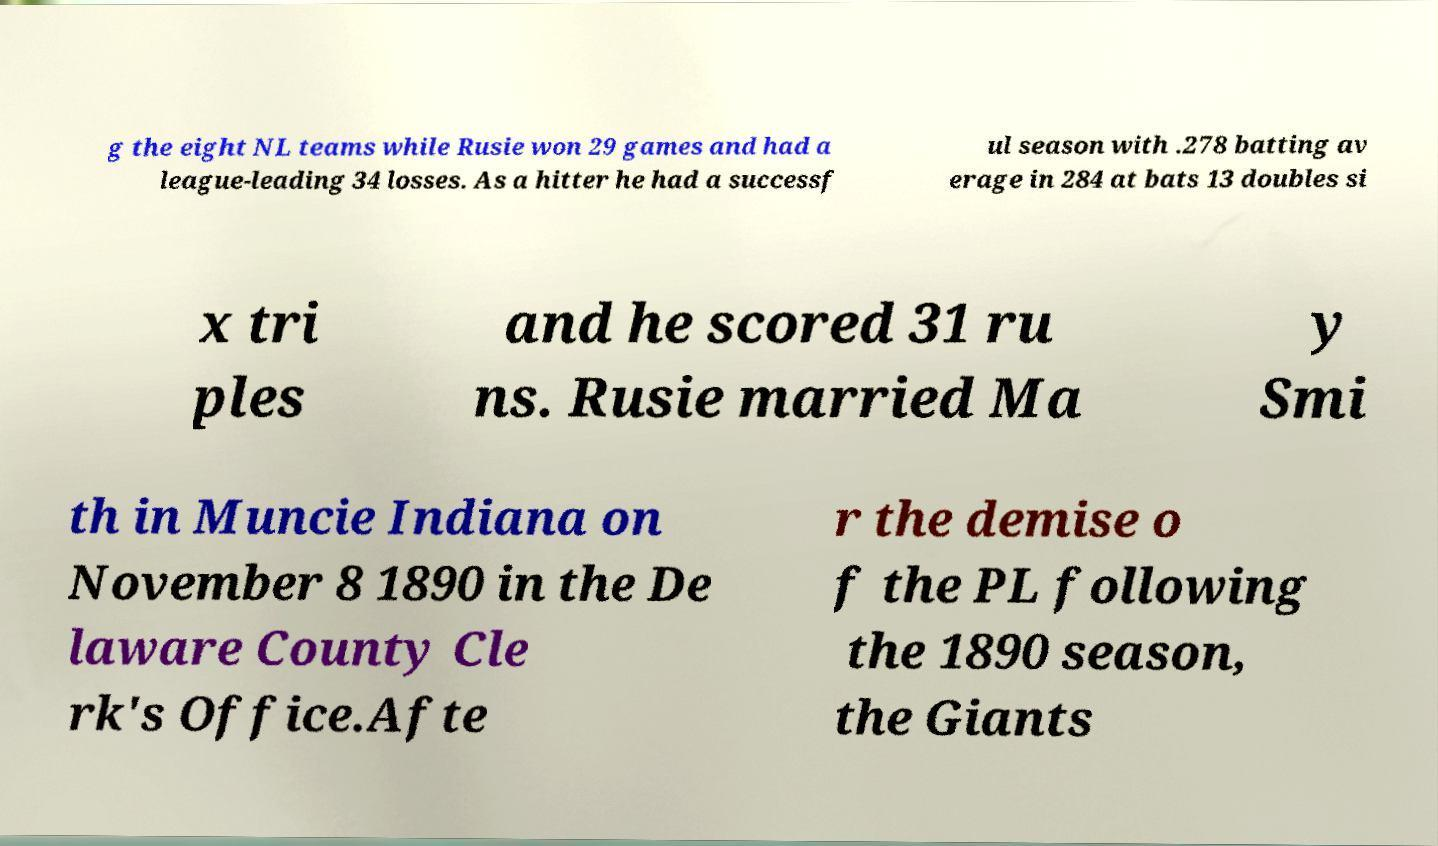Please identify and transcribe the text found in this image. g the eight NL teams while Rusie won 29 games and had a league-leading 34 losses. As a hitter he had a successf ul season with .278 batting av erage in 284 at bats 13 doubles si x tri ples and he scored 31 ru ns. Rusie married Ma y Smi th in Muncie Indiana on November 8 1890 in the De laware County Cle rk's Office.Afte r the demise o f the PL following the 1890 season, the Giants 